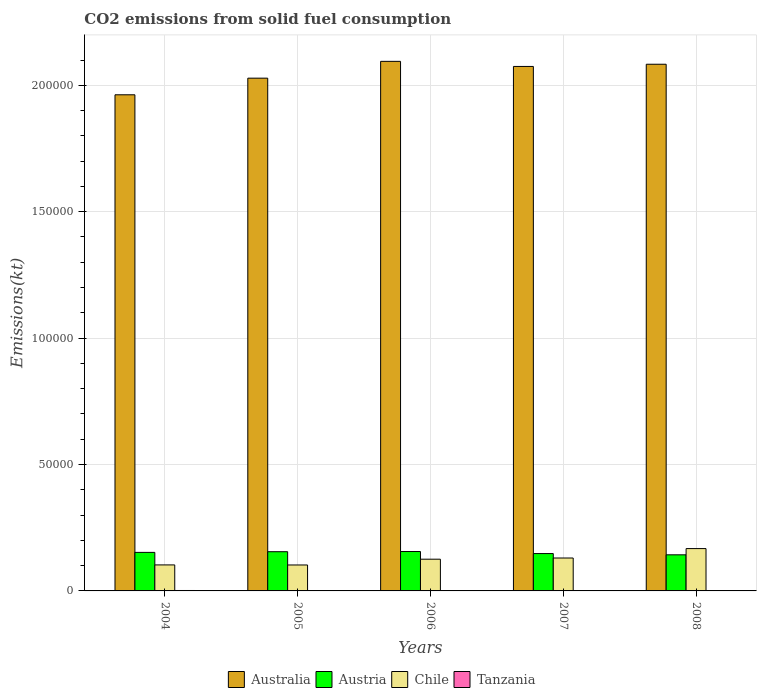How many different coloured bars are there?
Give a very brief answer. 4. How many groups of bars are there?
Offer a very short reply. 5. Are the number of bars on each tick of the X-axis equal?
Your response must be concise. Yes. How many bars are there on the 5th tick from the right?
Keep it short and to the point. 4. What is the amount of CO2 emitted in Tanzania in 2005?
Provide a succinct answer. 80.67. Across all years, what is the maximum amount of CO2 emitted in Austria?
Provide a short and direct response. 1.56e+04. Across all years, what is the minimum amount of CO2 emitted in Chile?
Your answer should be very brief. 1.03e+04. What is the total amount of CO2 emitted in Austria in the graph?
Give a very brief answer. 7.54e+04. What is the difference between the amount of CO2 emitted in Australia in 2004 and that in 2006?
Provide a short and direct response. -1.32e+04. What is the difference between the amount of CO2 emitted in Australia in 2007 and the amount of CO2 emitted in Austria in 2005?
Give a very brief answer. 1.92e+05. What is the average amount of CO2 emitted in Australia per year?
Offer a terse response. 2.05e+05. In the year 2006, what is the difference between the amount of CO2 emitted in Australia and amount of CO2 emitted in Austria?
Make the answer very short. 1.94e+05. In how many years, is the amount of CO2 emitted in Australia greater than 40000 kt?
Provide a succinct answer. 5. What is the ratio of the amount of CO2 emitted in Austria in 2007 to that in 2008?
Keep it short and to the point. 1.03. Is the difference between the amount of CO2 emitted in Australia in 2006 and 2007 greater than the difference between the amount of CO2 emitted in Austria in 2006 and 2007?
Provide a succinct answer. Yes. What is the difference between the highest and the second highest amount of CO2 emitted in Tanzania?
Ensure brevity in your answer.  91.68. What is the difference between the highest and the lowest amount of CO2 emitted in Austria?
Keep it short and to the point. 1305.45. In how many years, is the amount of CO2 emitted in Australia greater than the average amount of CO2 emitted in Australia taken over all years?
Offer a terse response. 3. Is it the case that in every year, the sum of the amount of CO2 emitted in Tanzania and amount of CO2 emitted in Chile is greater than the sum of amount of CO2 emitted in Austria and amount of CO2 emitted in Australia?
Your response must be concise. No. What does the 3rd bar from the right in 2008 represents?
Provide a short and direct response. Austria. Is it the case that in every year, the sum of the amount of CO2 emitted in Austria and amount of CO2 emitted in Australia is greater than the amount of CO2 emitted in Chile?
Your response must be concise. Yes. How many years are there in the graph?
Give a very brief answer. 5. What is the difference between two consecutive major ticks on the Y-axis?
Ensure brevity in your answer.  5.00e+04. Are the values on the major ticks of Y-axis written in scientific E-notation?
Your answer should be very brief. No. Does the graph contain grids?
Keep it short and to the point. Yes. Where does the legend appear in the graph?
Your response must be concise. Bottom center. How are the legend labels stacked?
Your answer should be compact. Horizontal. What is the title of the graph?
Your answer should be compact. CO2 emissions from solid fuel consumption. Does "Djibouti" appear as one of the legend labels in the graph?
Your response must be concise. No. What is the label or title of the X-axis?
Your response must be concise. Years. What is the label or title of the Y-axis?
Offer a terse response. Emissions(kt). What is the Emissions(kt) of Australia in 2004?
Give a very brief answer. 1.96e+05. What is the Emissions(kt) in Austria in 2004?
Give a very brief answer. 1.52e+04. What is the Emissions(kt) of Chile in 2004?
Your response must be concise. 1.03e+04. What is the Emissions(kt) in Tanzania in 2004?
Give a very brief answer. 172.35. What is the Emissions(kt) of Australia in 2005?
Ensure brevity in your answer.  2.03e+05. What is the Emissions(kt) in Austria in 2005?
Offer a terse response. 1.55e+04. What is the Emissions(kt) in Chile in 2005?
Offer a very short reply. 1.03e+04. What is the Emissions(kt) in Tanzania in 2005?
Keep it short and to the point. 80.67. What is the Emissions(kt) of Australia in 2006?
Ensure brevity in your answer.  2.09e+05. What is the Emissions(kt) of Austria in 2006?
Offer a terse response. 1.56e+04. What is the Emissions(kt) in Chile in 2006?
Make the answer very short. 1.25e+04. What is the Emissions(kt) of Tanzania in 2006?
Your response must be concise. 47.67. What is the Emissions(kt) of Australia in 2007?
Your answer should be compact. 2.07e+05. What is the Emissions(kt) in Austria in 2007?
Make the answer very short. 1.48e+04. What is the Emissions(kt) of Chile in 2007?
Offer a terse response. 1.30e+04. What is the Emissions(kt) in Tanzania in 2007?
Offer a very short reply. 73.34. What is the Emissions(kt) in Australia in 2008?
Your answer should be very brief. 2.08e+05. What is the Emissions(kt) in Austria in 2008?
Give a very brief answer. 1.43e+04. What is the Emissions(kt) of Chile in 2008?
Offer a terse response. 1.67e+04. What is the Emissions(kt) of Tanzania in 2008?
Keep it short and to the point. 40.34. Across all years, what is the maximum Emissions(kt) of Australia?
Provide a succinct answer. 2.09e+05. Across all years, what is the maximum Emissions(kt) of Austria?
Ensure brevity in your answer.  1.56e+04. Across all years, what is the maximum Emissions(kt) of Chile?
Your answer should be compact. 1.67e+04. Across all years, what is the maximum Emissions(kt) in Tanzania?
Give a very brief answer. 172.35. Across all years, what is the minimum Emissions(kt) in Australia?
Ensure brevity in your answer.  1.96e+05. Across all years, what is the minimum Emissions(kt) of Austria?
Provide a short and direct response. 1.43e+04. Across all years, what is the minimum Emissions(kt) of Chile?
Keep it short and to the point. 1.03e+04. Across all years, what is the minimum Emissions(kt) of Tanzania?
Your response must be concise. 40.34. What is the total Emissions(kt) of Australia in the graph?
Provide a short and direct response. 1.02e+06. What is the total Emissions(kt) of Austria in the graph?
Your answer should be very brief. 7.54e+04. What is the total Emissions(kt) in Chile in the graph?
Offer a very short reply. 6.29e+04. What is the total Emissions(kt) in Tanzania in the graph?
Keep it short and to the point. 414.37. What is the difference between the Emissions(kt) in Australia in 2004 and that in 2005?
Your answer should be very brief. -6578.6. What is the difference between the Emissions(kt) in Austria in 2004 and that in 2005?
Provide a short and direct response. -264.02. What is the difference between the Emissions(kt) in Chile in 2004 and that in 2005?
Your response must be concise. 29.34. What is the difference between the Emissions(kt) in Tanzania in 2004 and that in 2005?
Your answer should be very brief. 91.67. What is the difference between the Emissions(kt) of Australia in 2004 and that in 2006?
Provide a short and direct response. -1.32e+04. What is the difference between the Emissions(kt) of Austria in 2004 and that in 2006?
Offer a very short reply. -337.36. What is the difference between the Emissions(kt) in Chile in 2004 and that in 2006?
Offer a very short reply. -2258.87. What is the difference between the Emissions(kt) in Tanzania in 2004 and that in 2006?
Provide a short and direct response. 124.68. What is the difference between the Emissions(kt) in Australia in 2004 and that in 2007?
Give a very brief answer. -1.12e+04. What is the difference between the Emissions(kt) of Austria in 2004 and that in 2007?
Your response must be concise. 473.04. What is the difference between the Emissions(kt) of Chile in 2004 and that in 2007?
Keep it short and to the point. -2728.25. What is the difference between the Emissions(kt) in Tanzania in 2004 and that in 2007?
Make the answer very short. 99.01. What is the difference between the Emissions(kt) in Australia in 2004 and that in 2008?
Give a very brief answer. -1.21e+04. What is the difference between the Emissions(kt) in Austria in 2004 and that in 2008?
Offer a terse response. 968.09. What is the difference between the Emissions(kt) in Chile in 2004 and that in 2008?
Your response must be concise. -6457.59. What is the difference between the Emissions(kt) of Tanzania in 2004 and that in 2008?
Provide a short and direct response. 132.01. What is the difference between the Emissions(kt) in Australia in 2005 and that in 2006?
Ensure brevity in your answer.  -6648.27. What is the difference between the Emissions(kt) of Austria in 2005 and that in 2006?
Offer a terse response. -73.34. What is the difference between the Emissions(kt) of Chile in 2005 and that in 2006?
Make the answer very short. -2288.21. What is the difference between the Emissions(kt) in Tanzania in 2005 and that in 2006?
Offer a terse response. 33. What is the difference between the Emissions(kt) of Australia in 2005 and that in 2007?
Your answer should be very brief. -4635.09. What is the difference between the Emissions(kt) of Austria in 2005 and that in 2007?
Provide a short and direct response. 737.07. What is the difference between the Emissions(kt) in Chile in 2005 and that in 2007?
Keep it short and to the point. -2757.58. What is the difference between the Emissions(kt) in Tanzania in 2005 and that in 2007?
Offer a terse response. 7.33. What is the difference between the Emissions(kt) in Australia in 2005 and that in 2008?
Give a very brief answer. -5507.83. What is the difference between the Emissions(kt) in Austria in 2005 and that in 2008?
Provide a short and direct response. 1232.11. What is the difference between the Emissions(kt) of Chile in 2005 and that in 2008?
Offer a terse response. -6486.92. What is the difference between the Emissions(kt) in Tanzania in 2005 and that in 2008?
Your answer should be very brief. 40.34. What is the difference between the Emissions(kt) in Australia in 2006 and that in 2007?
Offer a very short reply. 2013.18. What is the difference between the Emissions(kt) of Austria in 2006 and that in 2007?
Ensure brevity in your answer.  810.41. What is the difference between the Emissions(kt) in Chile in 2006 and that in 2007?
Your answer should be compact. -469.38. What is the difference between the Emissions(kt) of Tanzania in 2006 and that in 2007?
Offer a very short reply. -25.67. What is the difference between the Emissions(kt) of Australia in 2006 and that in 2008?
Offer a very short reply. 1140.44. What is the difference between the Emissions(kt) of Austria in 2006 and that in 2008?
Give a very brief answer. 1305.45. What is the difference between the Emissions(kt) in Chile in 2006 and that in 2008?
Your answer should be compact. -4198.72. What is the difference between the Emissions(kt) in Tanzania in 2006 and that in 2008?
Provide a succinct answer. 7.33. What is the difference between the Emissions(kt) of Australia in 2007 and that in 2008?
Offer a very short reply. -872.75. What is the difference between the Emissions(kt) of Austria in 2007 and that in 2008?
Provide a succinct answer. 495.05. What is the difference between the Emissions(kt) in Chile in 2007 and that in 2008?
Your answer should be very brief. -3729.34. What is the difference between the Emissions(kt) of Tanzania in 2007 and that in 2008?
Offer a terse response. 33. What is the difference between the Emissions(kt) of Australia in 2004 and the Emissions(kt) of Austria in 2005?
Make the answer very short. 1.81e+05. What is the difference between the Emissions(kt) in Australia in 2004 and the Emissions(kt) in Chile in 2005?
Offer a very short reply. 1.86e+05. What is the difference between the Emissions(kt) in Australia in 2004 and the Emissions(kt) in Tanzania in 2005?
Offer a very short reply. 1.96e+05. What is the difference between the Emissions(kt) in Austria in 2004 and the Emissions(kt) in Chile in 2005?
Keep it short and to the point. 4987.12. What is the difference between the Emissions(kt) in Austria in 2004 and the Emissions(kt) in Tanzania in 2005?
Provide a succinct answer. 1.52e+04. What is the difference between the Emissions(kt) of Chile in 2004 and the Emissions(kt) of Tanzania in 2005?
Make the answer very short. 1.02e+04. What is the difference between the Emissions(kt) in Australia in 2004 and the Emissions(kt) in Austria in 2006?
Your response must be concise. 1.81e+05. What is the difference between the Emissions(kt) of Australia in 2004 and the Emissions(kt) of Chile in 2006?
Your response must be concise. 1.84e+05. What is the difference between the Emissions(kt) of Australia in 2004 and the Emissions(kt) of Tanzania in 2006?
Your answer should be compact. 1.96e+05. What is the difference between the Emissions(kt) of Austria in 2004 and the Emissions(kt) of Chile in 2006?
Provide a short and direct response. 2698.91. What is the difference between the Emissions(kt) in Austria in 2004 and the Emissions(kt) in Tanzania in 2006?
Your answer should be very brief. 1.52e+04. What is the difference between the Emissions(kt) of Chile in 2004 and the Emissions(kt) of Tanzania in 2006?
Your answer should be compact. 1.02e+04. What is the difference between the Emissions(kt) of Australia in 2004 and the Emissions(kt) of Austria in 2007?
Provide a short and direct response. 1.81e+05. What is the difference between the Emissions(kt) of Australia in 2004 and the Emissions(kt) of Chile in 2007?
Offer a very short reply. 1.83e+05. What is the difference between the Emissions(kt) of Australia in 2004 and the Emissions(kt) of Tanzania in 2007?
Ensure brevity in your answer.  1.96e+05. What is the difference between the Emissions(kt) in Austria in 2004 and the Emissions(kt) in Chile in 2007?
Offer a very short reply. 2229.54. What is the difference between the Emissions(kt) in Austria in 2004 and the Emissions(kt) in Tanzania in 2007?
Your answer should be very brief. 1.52e+04. What is the difference between the Emissions(kt) in Chile in 2004 and the Emissions(kt) in Tanzania in 2007?
Provide a succinct answer. 1.02e+04. What is the difference between the Emissions(kt) in Australia in 2004 and the Emissions(kt) in Austria in 2008?
Ensure brevity in your answer.  1.82e+05. What is the difference between the Emissions(kt) in Australia in 2004 and the Emissions(kt) in Chile in 2008?
Your response must be concise. 1.80e+05. What is the difference between the Emissions(kt) of Australia in 2004 and the Emissions(kt) of Tanzania in 2008?
Make the answer very short. 1.96e+05. What is the difference between the Emissions(kt) in Austria in 2004 and the Emissions(kt) in Chile in 2008?
Offer a very short reply. -1499.8. What is the difference between the Emissions(kt) in Austria in 2004 and the Emissions(kt) in Tanzania in 2008?
Provide a succinct answer. 1.52e+04. What is the difference between the Emissions(kt) of Chile in 2004 and the Emissions(kt) of Tanzania in 2008?
Give a very brief answer. 1.02e+04. What is the difference between the Emissions(kt) in Australia in 2005 and the Emissions(kt) in Austria in 2006?
Give a very brief answer. 1.87e+05. What is the difference between the Emissions(kt) in Australia in 2005 and the Emissions(kt) in Chile in 2006?
Your answer should be very brief. 1.90e+05. What is the difference between the Emissions(kt) of Australia in 2005 and the Emissions(kt) of Tanzania in 2006?
Your answer should be very brief. 2.03e+05. What is the difference between the Emissions(kt) in Austria in 2005 and the Emissions(kt) in Chile in 2006?
Your answer should be very brief. 2962.94. What is the difference between the Emissions(kt) in Austria in 2005 and the Emissions(kt) in Tanzania in 2006?
Ensure brevity in your answer.  1.55e+04. What is the difference between the Emissions(kt) of Chile in 2005 and the Emissions(kt) of Tanzania in 2006?
Your response must be concise. 1.02e+04. What is the difference between the Emissions(kt) of Australia in 2005 and the Emissions(kt) of Austria in 2007?
Your response must be concise. 1.88e+05. What is the difference between the Emissions(kt) in Australia in 2005 and the Emissions(kt) in Chile in 2007?
Provide a short and direct response. 1.90e+05. What is the difference between the Emissions(kt) of Australia in 2005 and the Emissions(kt) of Tanzania in 2007?
Give a very brief answer. 2.03e+05. What is the difference between the Emissions(kt) in Austria in 2005 and the Emissions(kt) in Chile in 2007?
Ensure brevity in your answer.  2493.56. What is the difference between the Emissions(kt) of Austria in 2005 and the Emissions(kt) of Tanzania in 2007?
Offer a very short reply. 1.54e+04. What is the difference between the Emissions(kt) in Chile in 2005 and the Emissions(kt) in Tanzania in 2007?
Offer a terse response. 1.02e+04. What is the difference between the Emissions(kt) in Australia in 2005 and the Emissions(kt) in Austria in 2008?
Provide a short and direct response. 1.89e+05. What is the difference between the Emissions(kt) of Australia in 2005 and the Emissions(kt) of Chile in 2008?
Give a very brief answer. 1.86e+05. What is the difference between the Emissions(kt) of Australia in 2005 and the Emissions(kt) of Tanzania in 2008?
Give a very brief answer. 2.03e+05. What is the difference between the Emissions(kt) of Austria in 2005 and the Emissions(kt) of Chile in 2008?
Provide a succinct answer. -1235.78. What is the difference between the Emissions(kt) of Austria in 2005 and the Emissions(kt) of Tanzania in 2008?
Give a very brief answer. 1.55e+04. What is the difference between the Emissions(kt) in Chile in 2005 and the Emissions(kt) in Tanzania in 2008?
Your answer should be compact. 1.02e+04. What is the difference between the Emissions(kt) of Australia in 2006 and the Emissions(kt) of Austria in 2007?
Your response must be concise. 1.95e+05. What is the difference between the Emissions(kt) of Australia in 2006 and the Emissions(kt) of Chile in 2007?
Your response must be concise. 1.96e+05. What is the difference between the Emissions(kt) in Australia in 2006 and the Emissions(kt) in Tanzania in 2007?
Offer a terse response. 2.09e+05. What is the difference between the Emissions(kt) of Austria in 2006 and the Emissions(kt) of Chile in 2007?
Your answer should be compact. 2566.9. What is the difference between the Emissions(kt) in Austria in 2006 and the Emissions(kt) in Tanzania in 2007?
Provide a succinct answer. 1.55e+04. What is the difference between the Emissions(kt) of Chile in 2006 and the Emissions(kt) of Tanzania in 2007?
Provide a succinct answer. 1.25e+04. What is the difference between the Emissions(kt) in Australia in 2006 and the Emissions(kt) in Austria in 2008?
Your answer should be compact. 1.95e+05. What is the difference between the Emissions(kt) in Australia in 2006 and the Emissions(kt) in Chile in 2008?
Your answer should be compact. 1.93e+05. What is the difference between the Emissions(kt) of Australia in 2006 and the Emissions(kt) of Tanzania in 2008?
Keep it short and to the point. 2.09e+05. What is the difference between the Emissions(kt) of Austria in 2006 and the Emissions(kt) of Chile in 2008?
Your answer should be compact. -1162.44. What is the difference between the Emissions(kt) of Austria in 2006 and the Emissions(kt) of Tanzania in 2008?
Ensure brevity in your answer.  1.55e+04. What is the difference between the Emissions(kt) of Chile in 2006 and the Emissions(kt) of Tanzania in 2008?
Ensure brevity in your answer.  1.25e+04. What is the difference between the Emissions(kt) in Australia in 2007 and the Emissions(kt) in Austria in 2008?
Offer a terse response. 1.93e+05. What is the difference between the Emissions(kt) of Australia in 2007 and the Emissions(kt) of Chile in 2008?
Offer a terse response. 1.91e+05. What is the difference between the Emissions(kt) in Australia in 2007 and the Emissions(kt) in Tanzania in 2008?
Give a very brief answer. 2.07e+05. What is the difference between the Emissions(kt) of Austria in 2007 and the Emissions(kt) of Chile in 2008?
Provide a short and direct response. -1972.85. What is the difference between the Emissions(kt) in Austria in 2007 and the Emissions(kt) in Tanzania in 2008?
Give a very brief answer. 1.47e+04. What is the difference between the Emissions(kt) in Chile in 2007 and the Emissions(kt) in Tanzania in 2008?
Offer a terse response. 1.30e+04. What is the average Emissions(kt) in Australia per year?
Provide a short and direct response. 2.05e+05. What is the average Emissions(kt) of Austria per year?
Your response must be concise. 1.51e+04. What is the average Emissions(kt) of Chile per year?
Ensure brevity in your answer.  1.26e+04. What is the average Emissions(kt) of Tanzania per year?
Provide a short and direct response. 82.87. In the year 2004, what is the difference between the Emissions(kt) in Australia and Emissions(kt) in Austria?
Your answer should be compact. 1.81e+05. In the year 2004, what is the difference between the Emissions(kt) in Australia and Emissions(kt) in Chile?
Provide a short and direct response. 1.86e+05. In the year 2004, what is the difference between the Emissions(kt) of Australia and Emissions(kt) of Tanzania?
Make the answer very short. 1.96e+05. In the year 2004, what is the difference between the Emissions(kt) of Austria and Emissions(kt) of Chile?
Offer a terse response. 4957.78. In the year 2004, what is the difference between the Emissions(kt) in Austria and Emissions(kt) in Tanzania?
Keep it short and to the point. 1.51e+04. In the year 2004, what is the difference between the Emissions(kt) of Chile and Emissions(kt) of Tanzania?
Provide a succinct answer. 1.01e+04. In the year 2005, what is the difference between the Emissions(kt) in Australia and Emissions(kt) in Austria?
Offer a terse response. 1.87e+05. In the year 2005, what is the difference between the Emissions(kt) in Australia and Emissions(kt) in Chile?
Your response must be concise. 1.93e+05. In the year 2005, what is the difference between the Emissions(kt) of Australia and Emissions(kt) of Tanzania?
Provide a succinct answer. 2.03e+05. In the year 2005, what is the difference between the Emissions(kt) of Austria and Emissions(kt) of Chile?
Provide a short and direct response. 5251.14. In the year 2005, what is the difference between the Emissions(kt) of Austria and Emissions(kt) of Tanzania?
Provide a succinct answer. 1.54e+04. In the year 2005, what is the difference between the Emissions(kt) of Chile and Emissions(kt) of Tanzania?
Your response must be concise. 1.02e+04. In the year 2006, what is the difference between the Emissions(kt) of Australia and Emissions(kt) of Austria?
Offer a very short reply. 1.94e+05. In the year 2006, what is the difference between the Emissions(kt) of Australia and Emissions(kt) of Chile?
Provide a succinct answer. 1.97e+05. In the year 2006, what is the difference between the Emissions(kt) of Australia and Emissions(kt) of Tanzania?
Provide a succinct answer. 2.09e+05. In the year 2006, what is the difference between the Emissions(kt) in Austria and Emissions(kt) in Chile?
Your answer should be compact. 3036.28. In the year 2006, what is the difference between the Emissions(kt) in Austria and Emissions(kt) in Tanzania?
Ensure brevity in your answer.  1.55e+04. In the year 2006, what is the difference between the Emissions(kt) of Chile and Emissions(kt) of Tanzania?
Ensure brevity in your answer.  1.25e+04. In the year 2007, what is the difference between the Emissions(kt) of Australia and Emissions(kt) of Austria?
Offer a very short reply. 1.93e+05. In the year 2007, what is the difference between the Emissions(kt) of Australia and Emissions(kt) of Chile?
Your answer should be very brief. 1.94e+05. In the year 2007, what is the difference between the Emissions(kt) in Australia and Emissions(kt) in Tanzania?
Keep it short and to the point. 2.07e+05. In the year 2007, what is the difference between the Emissions(kt) of Austria and Emissions(kt) of Chile?
Your answer should be compact. 1756.49. In the year 2007, what is the difference between the Emissions(kt) of Austria and Emissions(kt) of Tanzania?
Your answer should be compact. 1.47e+04. In the year 2007, what is the difference between the Emissions(kt) in Chile and Emissions(kt) in Tanzania?
Provide a succinct answer. 1.29e+04. In the year 2008, what is the difference between the Emissions(kt) in Australia and Emissions(kt) in Austria?
Offer a very short reply. 1.94e+05. In the year 2008, what is the difference between the Emissions(kt) in Australia and Emissions(kt) in Chile?
Keep it short and to the point. 1.92e+05. In the year 2008, what is the difference between the Emissions(kt) in Australia and Emissions(kt) in Tanzania?
Provide a succinct answer. 2.08e+05. In the year 2008, what is the difference between the Emissions(kt) of Austria and Emissions(kt) of Chile?
Provide a short and direct response. -2467.89. In the year 2008, what is the difference between the Emissions(kt) of Austria and Emissions(kt) of Tanzania?
Make the answer very short. 1.42e+04. In the year 2008, what is the difference between the Emissions(kt) of Chile and Emissions(kt) of Tanzania?
Keep it short and to the point. 1.67e+04. What is the ratio of the Emissions(kt) of Australia in 2004 to that in 2005?
Make the answer very short. 0.97. What is the ratio of the Emissions(kt) of Austria in 2004 to that in 2005?
Make the answer very short. 0.98. What is the ratio of the Emissions(kt) in Chile in 2004 to that in 2005?
Offer a terse response. 1. What is the ratio of the Emissions(kt) of Tanzania in 2004 to that in 2005?
Offer a terse response. 2.14. What is the ratio of the Emissions(kt) of Australia in 2004 to that in 2006?
Make the answer very short. 0.94. What is the ratio of the Emissions(kt) of Austria in 2004 to that in 2006?
Your response must be concise. 0.98. What is the ratio of the Emissions(kt) in Chile in 2004 to that in 2006?
Ensure brevity in your answer.  0.82. What is the ratio of the Emissions(kt) in Tanzania in 2004 to that in 2006?
Keep it short and to the point. 3.62. What is the ratio of the Emissions(kt) in Australia in 2004 to that in 2007?
Provide a succinct answer. 0.95. What is the ratio of the Emissions(kt) in Austria in 2004 to that in 2007?
Give a very brief answer. 1.03. What is the ratio of the Emissions(kt) of Chile in 2004 to that in 2007?
Your answer should be compact. 0.79. What is the ratio of the Emissions(kt) of Tanzania in 2004 to that in 2007?
Provide a succinct answer. 2.35. What is the ratio of the Emissions(kt) in Australia in 2004 to that in 2008?
Provide a succinct answer. 0.94. What is the ratio of the Emissions(kt) in Austria in 2004 to that in 2008?
Provide a succinct answer. 1.07. What is the ratio of the Emissions(kt) of Chile in 2004 to that in 2008?
Ensure brevity in your answer.  0.61. What is the ratio of the Emissions(kt) in Tanzania in 2004 to that in 2008?
Make the answer very short. 4.27. What is the ratio of the Emissions(kt) of Australia in 2005 to that in 2006?
Your response must be concise. 0.97. What is the ratio of the Emissions(kt) in Chile in 2005 to that in 2006?
Offer a very short reply. 0.82. What is the ratio of the Emissions(kt) of Tanzania in 2005 to that in 2006?
Make the answer very short. 1.69. What is the ratio of the Emissions(kt) in Australia in 2005 to that in 2007?
Ensure brevity in your answer.  0.98. What is the ratio of the Emissions(kt) of Austria in 2005 to that in 2007?
Provide a short and direct response. 1.05. What is the ratio of the Emissions(kt) in Chile in 2005 to that in 2007?
Give a very brief answer. 0.79. What is the ratio of the Emissions(kt) in Tanzania in 2005 to that in 2007?
Offer a terse response. 1.1. What is the ratio of the Emissions(kt) of Australia in 2005 to that in 2008?
Your answer should be compact. 0.97. What is the ratio of the Emissions(kt) in Austria in 2005 to that in 2008?
Your answer should be very brief. 1.09. What is the ratio of the Emissions(kt) in Chile in 2005 to that in 2008?
Make the answer very short. 0.61. What is the ratio of the Emissions(kt) of Australia in 2006 to that in 2007?
Offer a very short reply. 1.01. What is the ratio of the Emissions(kt) of Austria in 2006 to that in 2007?
Your answer should be very brief. 1.05. What is the ratio of the Emissions(kt) of Chile in 2006 to that in 2007?
Give a very brief answer. 0.96. What is the ratio of the Emissions(kt) in Tanzania in 2006 to that in 2007?
Your answer should be very brief. 0.65. What is the ratio of the Emissions(kt) of Austria in 2006 to that in 2008?
Your answer should be compact. 1.09. What is the ratio of the Emissions(kt) in Chile in 2006 to that in 2008?
Ensure brevity in your answer.  0.75. What is the ratio of the Emissions(kt) of Tanzania in 2006 to that in 2008?
Provide a short and direct response. 1.18. What is the ratio of the Emissions(kt) of Austria in 2007 to that in 2008?
Keep it short and to the point. 1.03. What is the ratio of the Emissions(kt) in Chile in 2007 to that in 2008?
Offer a very short reply. 0.78. What is the ratio of the Emissions(kt) in Tanzania in 2007 to that in 2008?
Ensure brevity in your answer.  1.82. What is the difference between the highest and the second highest Emissions(kt) in Australia?
Give a very brief answer. 1140.44. What is the difference between the highest and the second highest Emissions(kt) of Austria?
Provide a succinct answer. 73.34. What is the difference between the highest and the second highest Emissions(kt) in Chile?
Your response must be concise. 3729.34. What is the difference between the highest and the second highest Emissions(kt) of Tanzania?
Your answer should be very brief. 91.67. What is the difference between the highest and the lowest Emissions(kt) of Australia?
Your answer should be compact. 1.32e+04. What is the difference between the highest and the lowest Emissions(kt) of Austria?
Provide a succinct answer. 1305.45. What is the difference between the highest and the lowest Emissions(kt) of Chile?
Give a very brief answer. 6486.92. What is the difference between the highest and the lowest Emissions(kt) of Tanzania?
Keep it short and to the point. 132.01. 